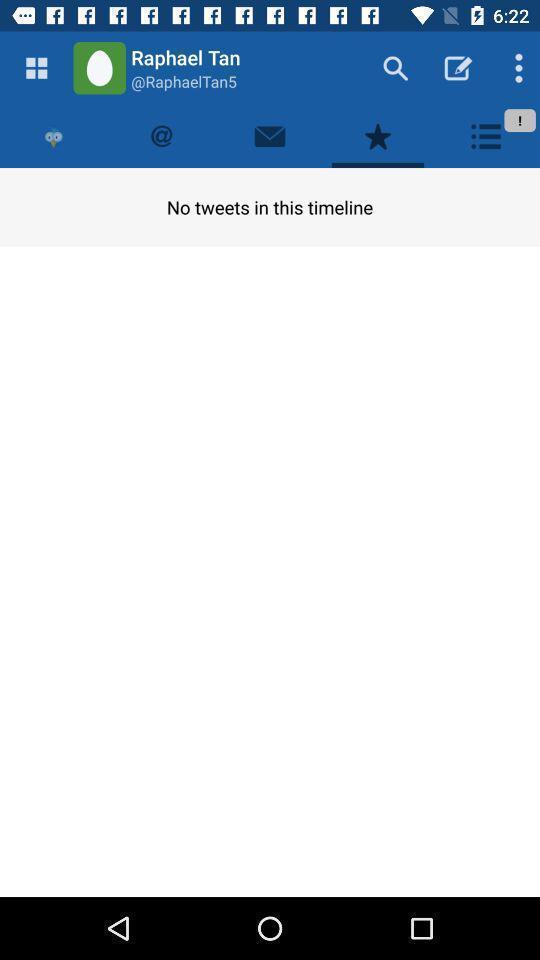Describe the visual elements of this screenshot. Time line tab in the social media application. 